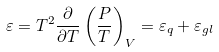Convert formula to latex. <formula><loc_0><loc_0><loc_500><loc_500>\varepsilon = T ^ { 2 } \frac { \partial } { \partial T } \left ( \frac { P } { T } \right ) _ { V } = \varepsilon _ { q } + \varepsilon _ { g l }</formula> 